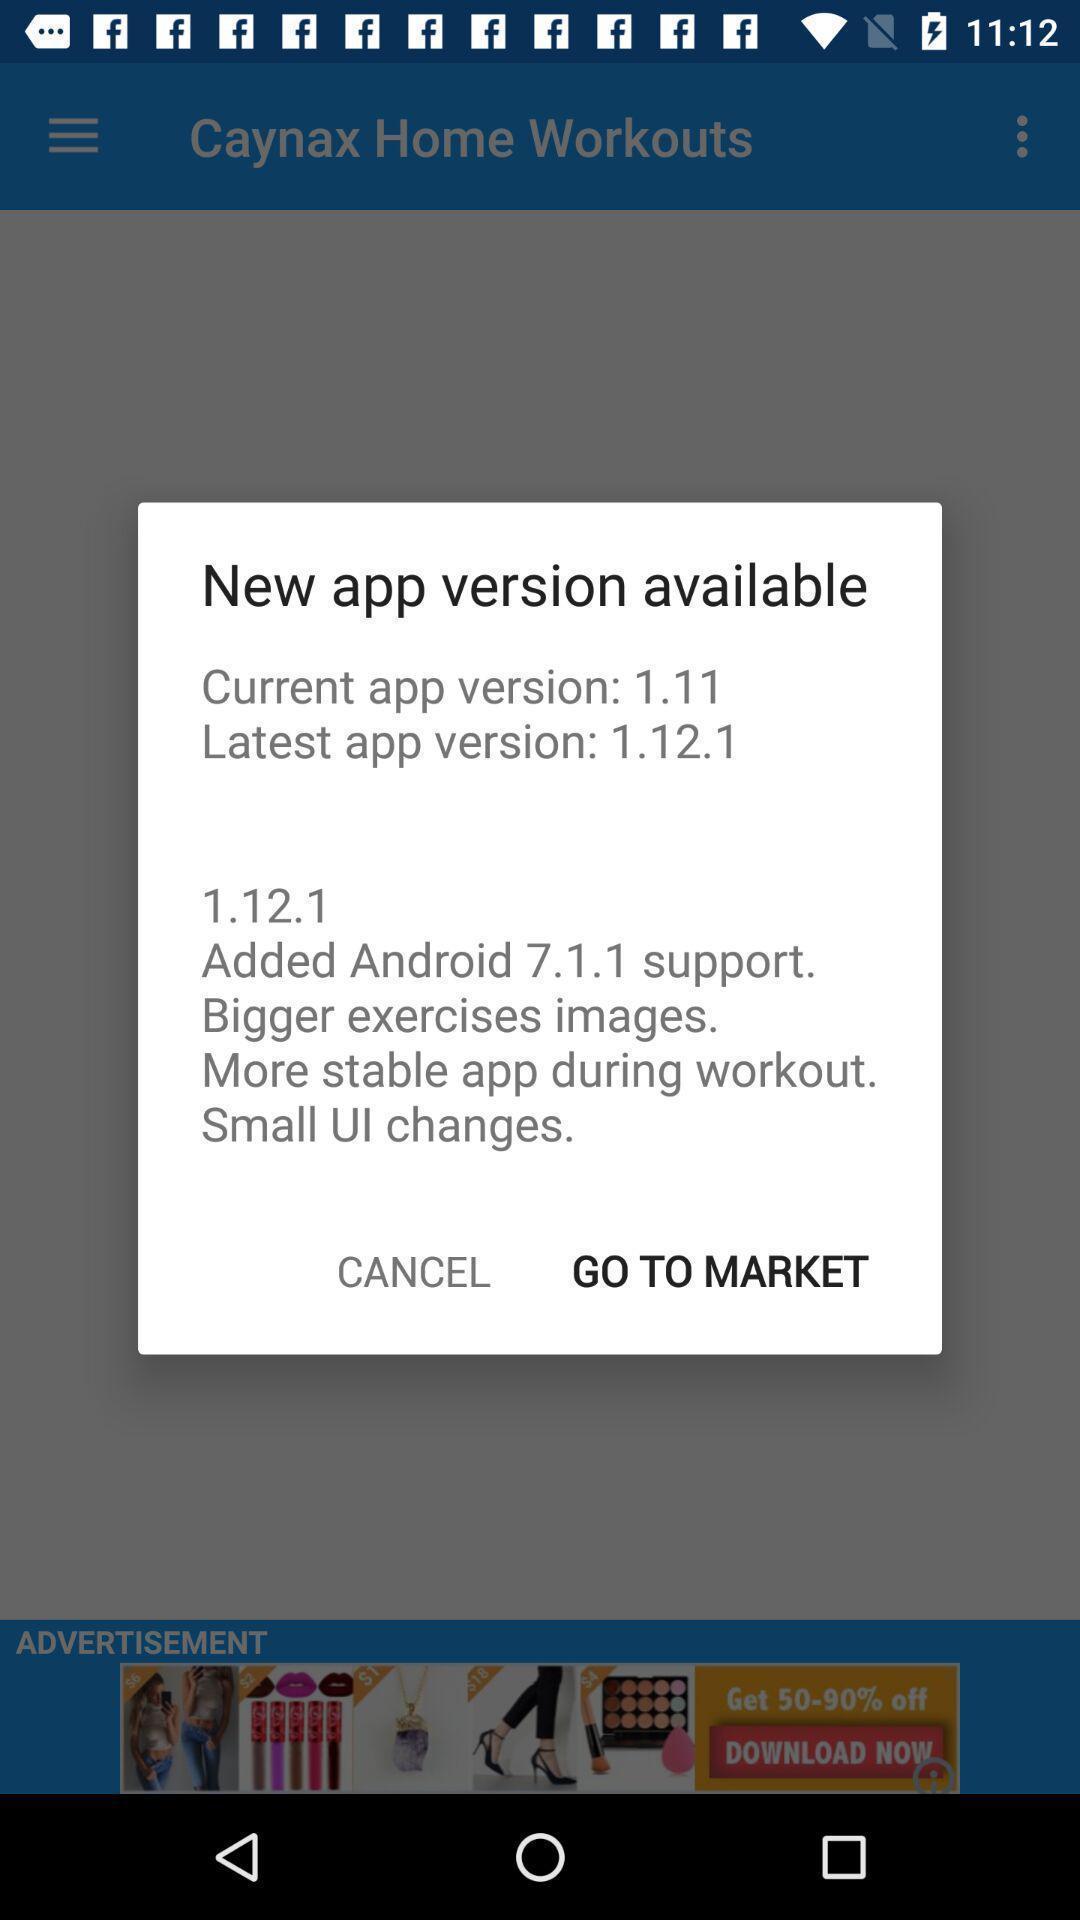Provide a description of this screenshot. Pop up showing latest app version updates. 